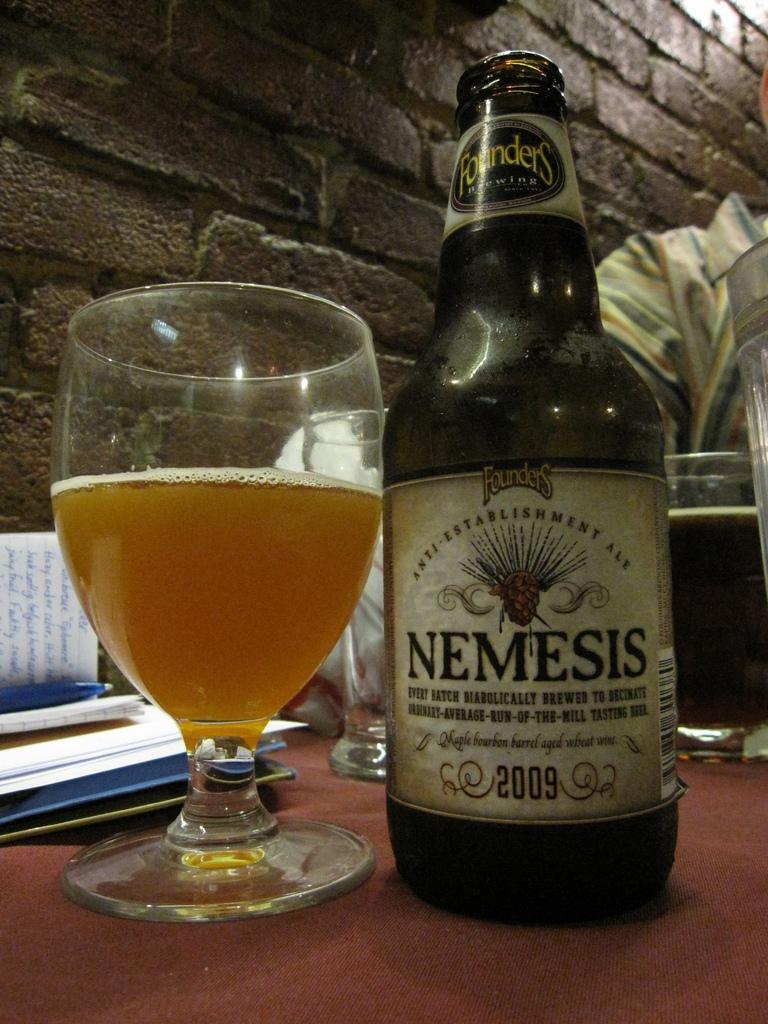Can you describe this image briefly? On the table we can see a wine glass, wine and wine bottle. Here we can see papers, book, pen and other objects. On the right there is a man is wearing shirt, sitting near to the brick wall. 